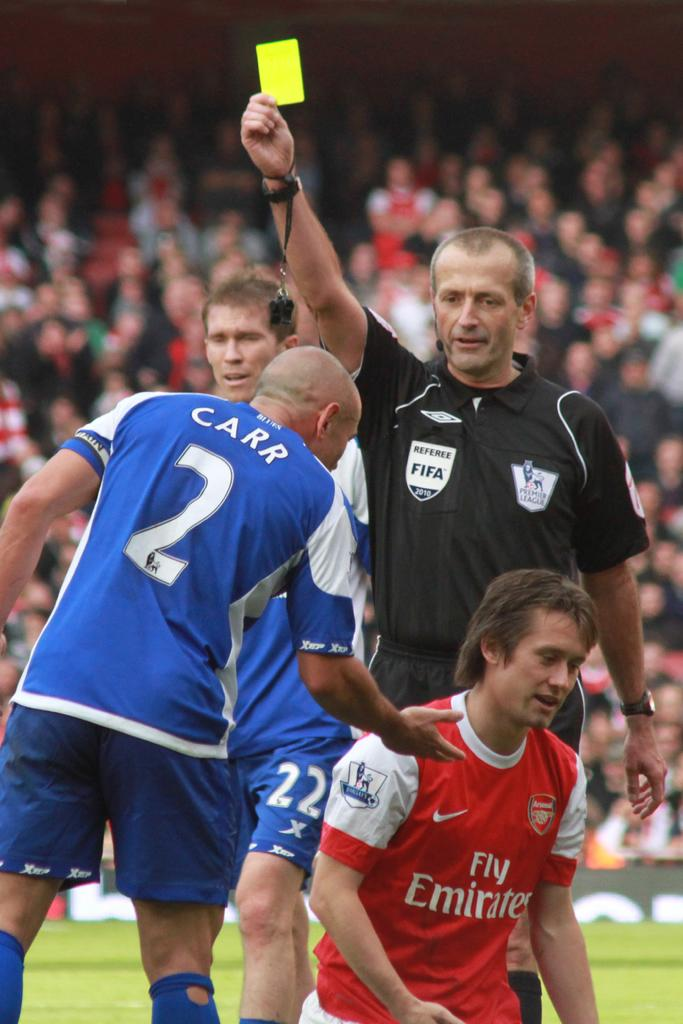<image>
Provide a brief description of the given image. a referee giving soccer teams a yellow card while the blue player Carr 2 offers a hand to help the red player up 